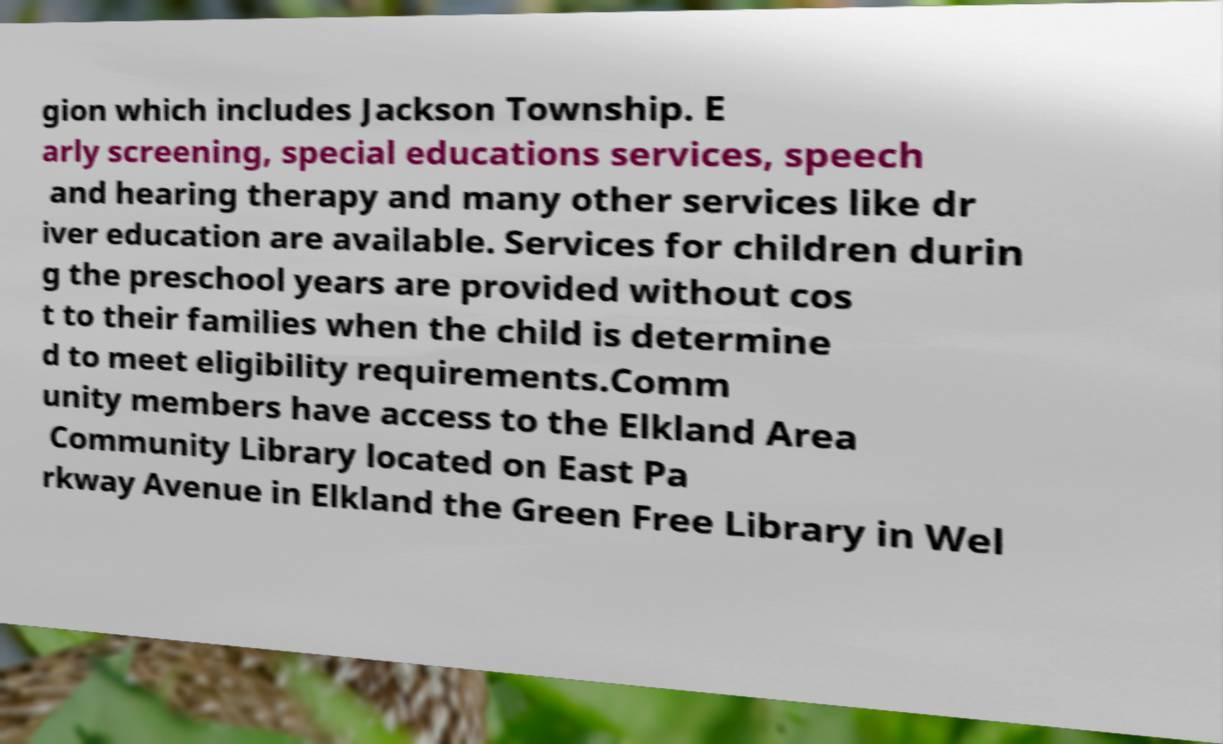Could you assist in decoding the text presented in this image and type it out clearly? gion which includes Jackson Township. E arly screening, special educations services, speech and hearing therapy and many other services like dr iver education are available. Services for children durin g the preschool years are provided without cos t to their families when the child is determine d to meet eligibility requirements.Comm unity members have access to the Elkland Area Community Library located on East Pa rkway Avenue in Elkland the Green Free Library in Wel 